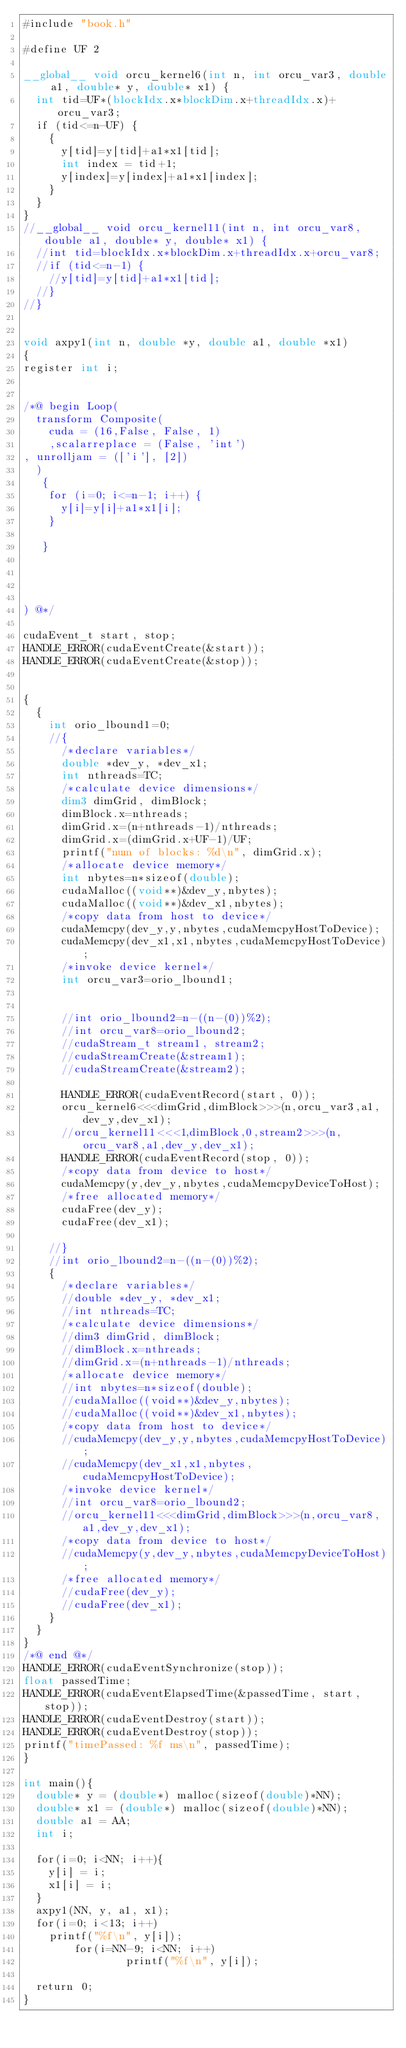Convert code to text. <code><loc_0><loc_0><loc_500><loc_500><_Cuda_>#include "book.h"

#define UF 2

__global__ void orcu_kernel6(int n, int orcu_var3, double a1, double* y, double* x1) {
  int tid=UF*(blockIdx.x*blockDim.x+threadIdx.x)+orcu_var3;
  if (tid<=n-UF) {
    {
      y[tid]=y[tid]+a1*x1[tid];
      int index = tid+1;
      y[index]=y[index]+a1*x1[index];
    }
  }
}
//__global__ void orcu_kernel11(int n, int orcu_var8, double a1, double* y, double* x1) {
  //int tid=blockIdx.x*blockDim.x+threadIdx.x+orcu_var8;
  //if (tid<=n-1) {
    //y[tid]=y[tid]+a1*x1[tid];
  //}
//}


void axpy1(int n, double *y, double a1, double *x1)
{
register int i;


/*@ begin Loop(
  transform Composite(
    cuda = (16,False, False, 1)
    ,scalarreplace = (False, 'int')
, unrolljam = (['i'], [2])
  )
   {
    for (i=0; i<=n-1; i++) {
    	y[i]=y[i]+a1*x1[i];
    }
    
   }


   
  
) @*/

cudaEvent_t start, stop;
HANDLE_ERROR(cudaEventCreate(&start));
HANDLE_ERROR(cudaEventCreate(&stop));


{
  {
    int orio_lbound1=0;
    //{
      /*declare variables*/
      double *dev_y, *dev_x1;
      int nthreads=TC;
      /*calculate device dimensions*/
      dim3 dimGrid, dimBlock;
      dimBlock.x=nthreads;
      dimGrid.x=(n+nthreads-1)/nthreads;
      dimGrid.x=(dimGrid.x+UF-1)/UF;
      printf("num of blocks: %d\n", dimGrid.x);
      /*allocate device memory*/
      int nbytes=n*sizeof(double);
      cudaMalloc((void**)&dev_y,nbytes);
      cudaMalloc((void**)&dev_x1,nbytes);
      /*copy data from host to device*/
      cudaMemcpy(dev_y,y,nbytes,cudaMemcpyHostToDevice);
      cudaMemcpy(dev_x1,x1,nbytes,cudaMemcpyHostToDevice);
      /*invoke device kernel*/
      int orcu_var3=orio_lbound1;

    
      //int orio_lbound2=n-((n-(0))%2);
      //int orcu_var8=orio_lbound2;
      //cudaStream_t stream1, stream2;
      //cudaStreamCreate(&stream1);
      //cudaStreamCreate(&stream2);

      HANDLE_ERROR(cudaEventRecord(start, 0));
      orcu_kernel6<<<dimGrid,dimBlock>>>(n,orcu_var3,a1,dev_y,dev_x1);
      //orcu_kernel11<<<1,dimBlock,0,stream2>>>(n,orcu_var8,a1,dev_y,dev_x1);
      HANDLE_ERROR(cudaEventRecord(stop, 0));
      /*copy data from device to host*/
      cudaMemcpy(y,dev_y,nbytes,cudaMemcpyDeviceToHost);
      /*free allocated memory*/
      cudaFree(dev_y);
      cudaFree(dev_x1);

    //}
    //int orio_lbound2=n-((n-(0))%2);
    {
      /*declare variables*/
      //double *dev_y, *dev_x1;
      //int nthreads=TC;
      /*calculate device dimensions*/
      //dim3 dimGrid, dimBlock;
      //dimBlock.x=nthreads;
      //dimGrid.x=(n+nthreads-1)/nthreads;
      /*allocate device memory*/
      //int nbytes=n*sizeof(double);
      //cudaMalloc((void**)&dev_y,nbytes);
      //cudaMalloc((void**)&dev_x1,nbytes);
      /*copy data from host to device*/
      //cudaMemcpy(dev_y,y,nbytes,cudaMemcpyHostToDevice);
      //cudaMemcpy(dev_x1,x1,nbytes,cudaMemcpyHostToDevice);
      /*invoke device kernel*/
      //int orcu_var8=orio_lbound2;
      //orcu_kernel11<<<dimGrid,dimBlock>>>(n,orcu_var8,a1,dev_y,dev_x1);
      /*copy data from device to host*/
      //cudaMemcpy(y,dev_y,nbytes,cudaMemcpyDeviceToHost);
      /*free allocated memory*/
      //cudaFree(dev_y);
      //cudaFree(dev_x1);
    }
  }
}
/*@ end @*/
HANDLE_ERROR(cudaEventSynchronize(stop));
float passedTime;
HANDLE_ERROR(cudaEventElapsedTime(&passedTime, start, stop));
HANDLE_ERROR(cudaEventDestroy(start));
HANDLE_ERROR(cudaEventDestroy(stop));
printf("timePassed: %f ms\n", passedTime);
}

int main(){
	double* y = (double*) malloc(sizeof(double)*NN);
	double* x1 = (double*) malloc(sizeof(double)*NN);
	double a1 = AA;
	int i;
        
	for(i=0; i<NN; i++){
		y[i] = i;
		x1[i] = i;
	}
	axpy1(NN, y, a1, x1);
	for(i=0; i<13; i++)
		printf("%f\n", y[i]);
        for(i=NN-9; i<NN; i++)
                printf("%f\n", y[i]);

	return 0;
}
</code> 